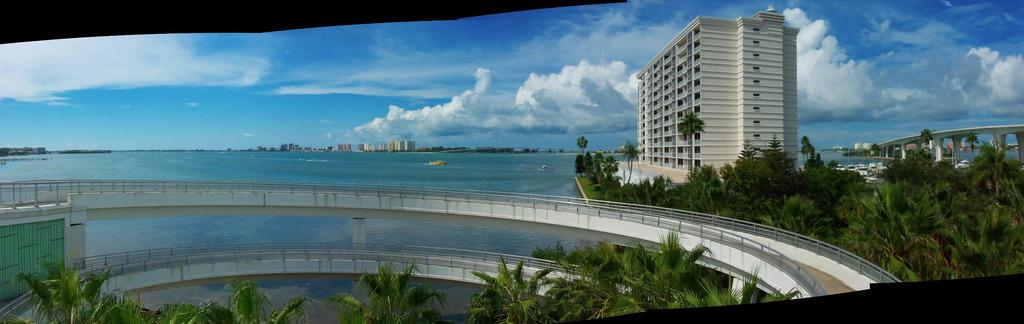What type of structures can be seen in the image? There are bridges in the image. What type of natural elements are present in the image? There are trees in the image. What type of transportation can be seen in the image? There are boats on water in the image. What type of man-made structures can be seen in the background of the image? There are buildings in the background of the image. What part of the natural environment is visible in the background of the image? The sky is visible in the background of the image, and clouds are present in the sky. What type of sign can be seen in the image? There is no sign present in the image. What type of alley can be seen in the image? There is no alley present in the image. 